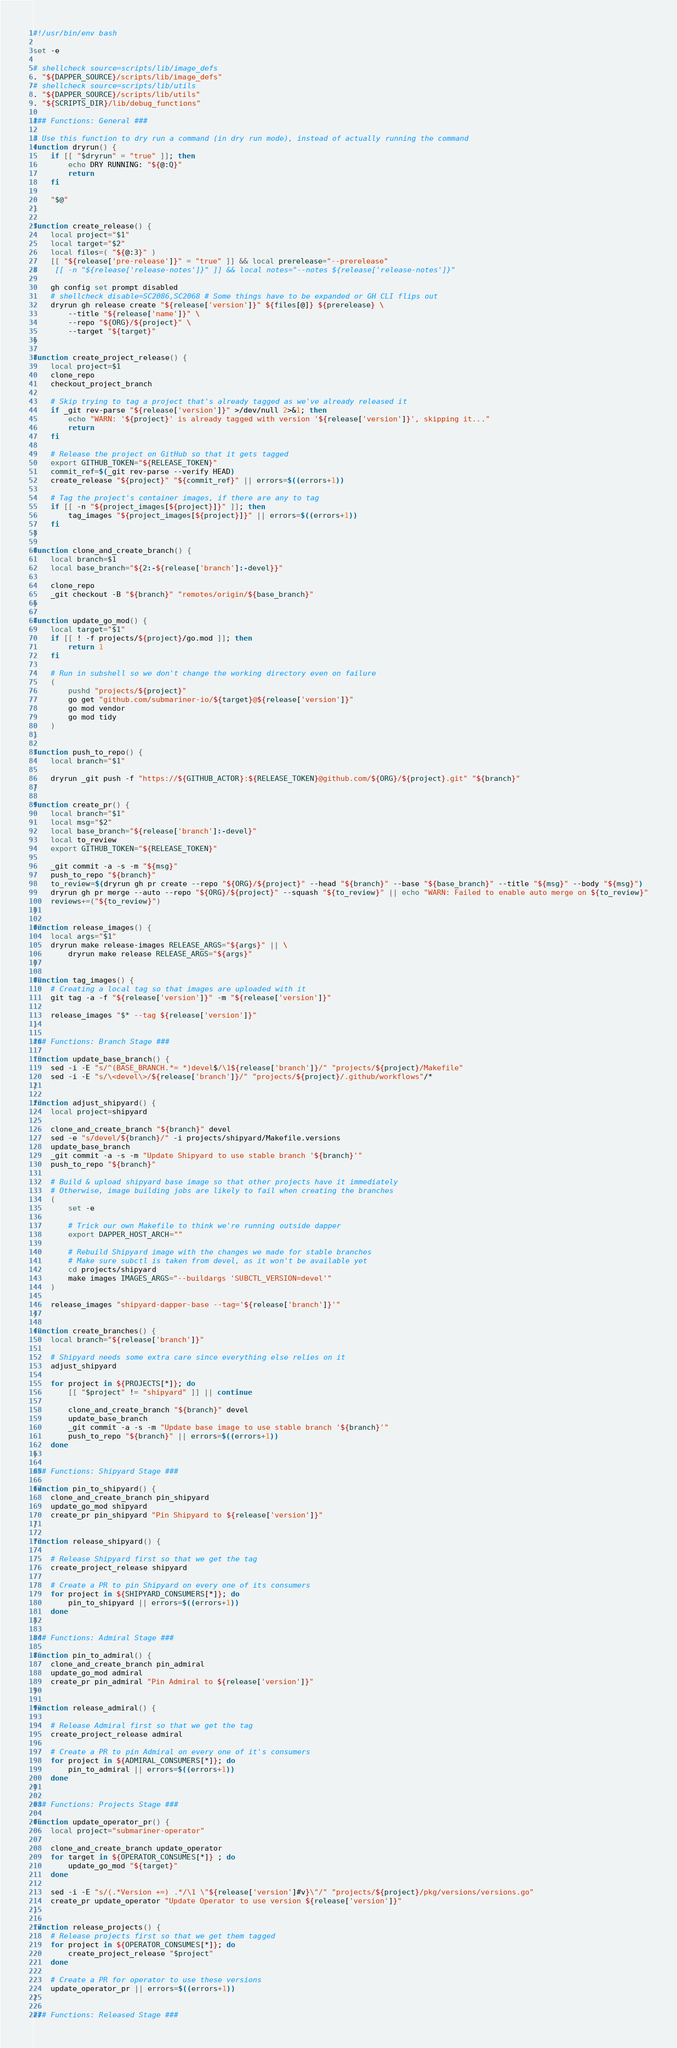<code> <loc_0><loc_0><loc_500><loc_500><_Bash_>#!/usr/bin/env bash

set -e

# shellcheck source=scripts/lib/image_defs
. "${DAPPER_SOURCE}/scripts/lib/image_defs"
# shellcheck source=scripts/lib/utils
. "${DAPPER_SOURCE}/scripts/lib/utils"
. "${SCRIPTS_DIR}/lib/debug_functions"

### Functions: General ###

# Use this function to dry run a command (in dry run mode), instead of actually running the command
function dryrun() {
    if [[ "$dryrun" = "true" ]]; then
        echo DRY RUNNING: "${@:Q}"
        return
    fi

    "$@"
}

function create_release() {
    local project="$1"
    local target="$2"
    local files=( "${@:3}" )
    [[ "${release['pre-release']}" = "true" ]] && local prerelease="--prerelease"
#    [[ -n "${release['release-notes']}" ]] && local notes="--notes ${release['release-notes']}"

    gh config set prompt disabled
    # shellcheck disable=SC2086,SC2068 # Some things have to be expanded or GH CLI flips out
    dryrun gh release create "${release['version']}" ${files[@]} ${prerelease} \
        --title "${release['name']}" \
        --repo "${ORG}/${project}" \
        --target "${target}"
}

function create_project_release() {
    local project=$1
    clone_repo
    checkout_project_branch

    # Skip trying to tag a project that's already tagged as we've already released it
    if _git rev-parse "${release['version']}" >/dev/null 2>&1; then
        echo "WARN: '${project}' is already tagged with version '${release['version']}', skipping it..."
        return
    fi

    # Release the project on GitHub so that it gets tagged
    export GITHUB_TOKEN="${RELEASE_TOKEN}"
    commit_ref=$(_git rev-parse --verify HEAD)
    create_release "${project}" "${commit_ref}" || errors=$((errors+1))

    # Tag the project's container images, if there are any to tag
    if [[ -n "${project_images[${project}]}" ]]; then
        tag_images "${project_images[${project}]}" || errors=$((errors+1))
    fi
}

function clone_and_create_branch() {
    local branch=$1
    local base_branch="${2:-${release['branch']:-devel}}"

    clone_repo
    _git checkout -B "${branch}" "remotes/origin/${base_branch}"
}

function update_go_mod() {
    local target="$1"
    if [[ ! -f projects/${project}/go.mod ]]; then
        return 1
    fi

    # Run in subshell so we don't change the working directory even on failure
    (
        pushd "projects/${project}"
        go get "github.com/submariner-io/${target}@${release['version']}"
        go mod vendor
        go mod tidy
    )
}

function push_to_repo() {
    local branch="$1"

    dryrun _git push -f "https://${GITHUB_ACTOR}:${RELEASE_TOKEN}@github.com/${ORG}/${project}.git" "${branch}"
}

function create_pr() {
    local branch="$1"
    local msg="$2"
    local base_branch="${release['branch']:-devel}"
    local to_review
    export GITHUB_TOKEN="${RELEASE_TOKEN}"

    _git commit -a -s -m "${msg}"
    push_to_repo "${branch}"
    to_review=$(dryrun gh pr create --repo "${ORG}/${project}" --head "${branch}" --base "${base_branch}" --title "${msg}" --body "${msg}")
    dryrun gh pr merge --auto --repo "${ORG}/${project}" --squash "${to_review}" || echo "WARN: Failed to enable auto merge on ${to_review}"
    reviews+=("${to_review}")
}

function release_images() {
    local args="$1"
    dryrun make release-images RELEASE_ARGS="${args}" || \
        dryrun make release RELEASE_ARGS="${args}"
}

function tag_images() {
    # Creating a local tag so that images are uploaded with it
    git tag -a -f "${release['version']}" -m "${release['version']}"

    release_images "$* --tag ${release['version']}"
}

### Functions: Branch Stage ###

function update_base_branch() {
    sed -i -E "s/^(BASE_BRANCH.*= *)devel$/\1${release['branch']}/" "projects/${project}/Makefile"
    sed -i -E "s/\<devel\>/${release['branch']}/" "projects/${project}/.github/workflows"/*
}

function adjust_shipyard() {
    local project=shipyard

    clone_and_create_branch "${branch}" devel
    sed -e "s/devel/${branch}/" -i projects/shipyard/Makefile.versions
    update_base_branch
    _git commit -a -s -m "Update Shipyard to use stable branch '${branch}'"
    push_to_repo "${branch}"

    # Build & upload shipyard base image so that other projects have it immediately
    # Otherwise, image building jobs are likely to fail when creating the branches
    (
        set -e

        # Trick our own Makefile to think we're running outside dapper
        export DAPPER_HOST_ARCH=""

        # Rebuild Shipyard image with the changes we made for stable branches
        # Make sure subctl is taken from devel, as it won't be available yet
        cd projects/shipyard
        make images IMAGES_ARGS="--buildargs 'SUBCTL_VERSION=devel'"
    )

    release_images "shipyard-dapper-base --tag='${release['branch']}'"
}

function create_branches() {
    local branch="${release['branch']}"

    # Shipyard needs some extra care since everything else relies on it
    adjust_shipyard

    for project in ${PROJECTS[*]}; do
        [[ "$project" != "shipyard" ]] || continue

        clone_and_create_branch "${branch}" devel
        update_base_branch
        _git commit -a -s -m "Update base image to use stable branch '${branch}'"
        push_to_repo "${branch}" || errors=$((errors+1))
    done
}

### Functions: Shipyard Stage ###

function pin_to_shipyard() {
    clone_and_create_branch pin_shipyard
    update_go_mod shipyard
    create_pr pin_shipyard "Pin Shipyard to ${release['version']}"
}

function release_shipyard() {

    # Release Shipyard first so that we get the tag
    create_project_release shipyard

    # Create a PR to pin Shipyard on every one of its consumers
    for project in ${SHIPYARD_CONSUMERS[*]}; do
        pin_to_shipyard || errors=$((errors+1))
    done
}

### Functions: Admiral Stage ###

function pin_to_admiral() {
    clone_and_create_branch pin_admiral
    update_go_mod admiral
    create_pr pin_admiral "Pin Admiral to ${release['version']}"
}

function release_admiral() {

    # Release Admiral first so that we get the tag
    create_project_release admiral

    # Create a PR to pin Admiral on every one of it's consumers
    for project in ${ADMIRAL_CONSUMERS[*]}; do
        pin_to_admiral || errors=$((errors+1))
    done
}

### Functions: Projects Stage ###

function update_operator_pr() {
    local project="submariner-operator"

    clone_and_create_branch update_operator
    for target in ${OPERATOR_CONSUMES[*]} ; do
        update_go_mod "${target}"
    done

    sed -i -E "s/(.*Version +=) .*/\1 \"${release['version']#v}\"/" "projects/${project}/pkg/versions/versions.go"
    create_pr update_operator "Update Operator to use version ${release['version']}"
}

function release_projects() {
    # Release projects first so that we get them tagged
    for project in ${OPERATOR_CONSUMES[*]}; do
        create_project_release "$project"
    done

    # Create a PR for operator to use these versions
    update_operator_pr || errors=$((errors+1))
}

### Functions: Released Stage ###
</code> 